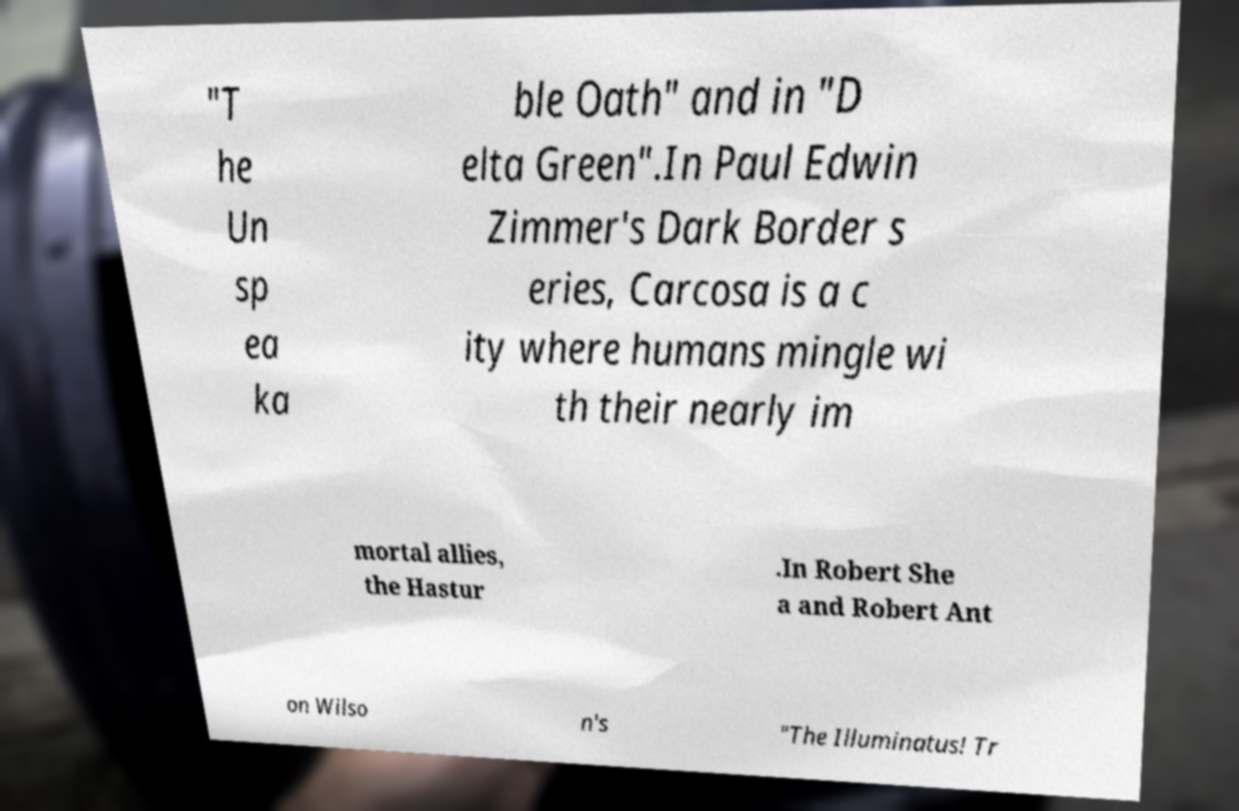There's text embedded in this image that I need extracted. Can you transcribe it verbatim? "T he Un sp ea ka ble Oath" and in "D elta Green".In Paul Edwin Zimmer's Dark Border s eries, Carcosa is a c ity where humans mingle wi th their nearly im mortal allies, the Hastur .In Robert She a and Robert Ant on Wilso n's "The Illuminatus! Tr 